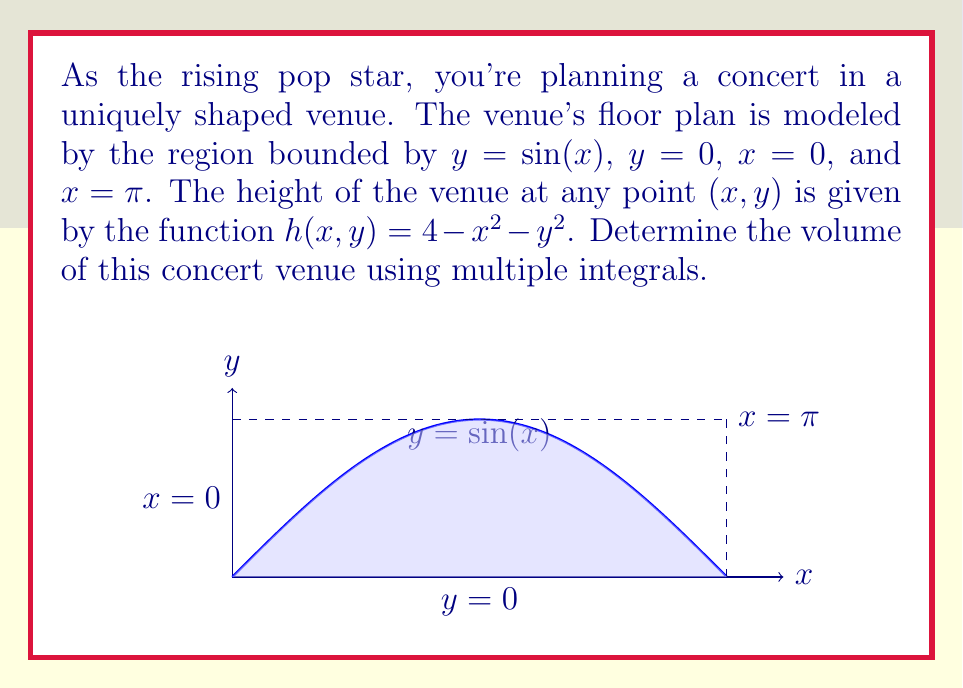Help me with this question. Let's approach this step-by-step:

1) The volume of the venue can be calculated using a double integral:

   $$V = \int\int_R h(x,y) \, dA$$

   where $R$ is the region bounded by $y = \sin(x)$, $y = 0$, $x = 0$, and $x = \pi$.

2) We'll set up the integral with $x$ as the outer integral and $y$ as the inner integral:

   $$V = \int_0^\pi \int_0^{\sin(x)} (4 - x^2 - y^2) \, dy \, dx$$

3) Let's solve the inner integral first:

   $$\int_0^{\sin(x)} (4 - x^2 - y^2) \, dy = [4y - x^2y - \frac{1}{3}y^3]_0^{\sin(x)}$$
   
   $$= (4\sin(x) - x^2\sin(x) - \frac{1}{3}\sin^3(x)) - 0$$

4) Now our integral becomes:

   $$V = \int_0^\pi (4\sin(x) - x^2\sin(x) - \frac{1}{3}\sin^3(x)) \, dx$$

5) This integral can be solved using integration by parts and trigonometric identities. The result is:

   $$V = [-4\cos(x) + \frac{1}{3}x^3\sin(x) - x^2\cos(x) + 2x\sin(x) + 2\cos(x) - \frac{1}{12}\cos(x)(9\sin^2(x)-1)]_0^\pi$$

6) Evaluating this at the limits:

   $$V = [-4(-1) + 0 - 0 + 0 + 2(-1) - \frac{1}{12}(-1)(0-1)] - [-4(1) + 0 - 0 + 0 + 2(1) - \frac{1}{12}(1)(0-1)]$$

7) Simplifying:

   $$V = 4 - 2 + \frac{1}{12} - (-4 - 2 + \frac{1}{12}) = 8 + \frac{1}{6} = \frac{49}{6}$$
Answer: $\frac{49}{6}$ cubic units 